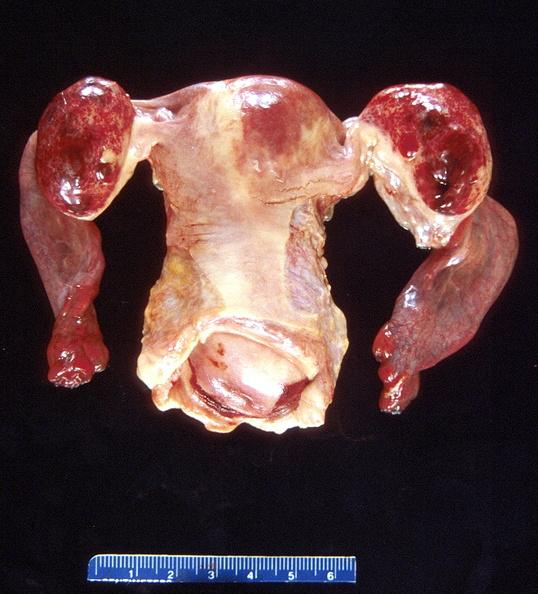does this image show ovarian cysts, hemorrhagic?
Answer the question using a single word or phrase. Yes 